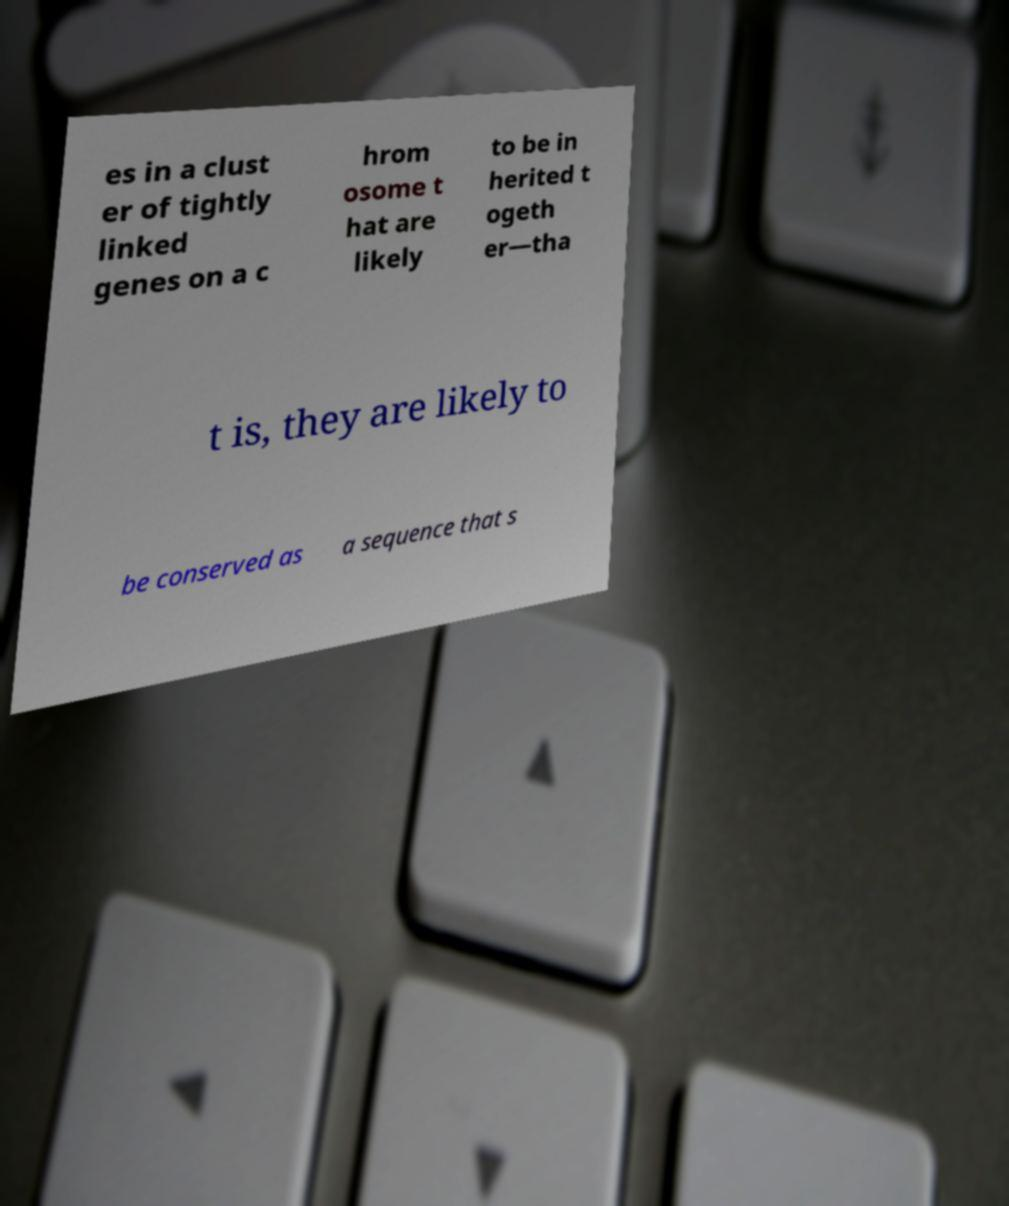Please read and relay the text visible in this image. What does it say? es in a clust er of tightly linked genes on a c hrom osome t hat are likely to be in herited t ogeth er—tha t is, they are likely to be conserved as a sequence that s 